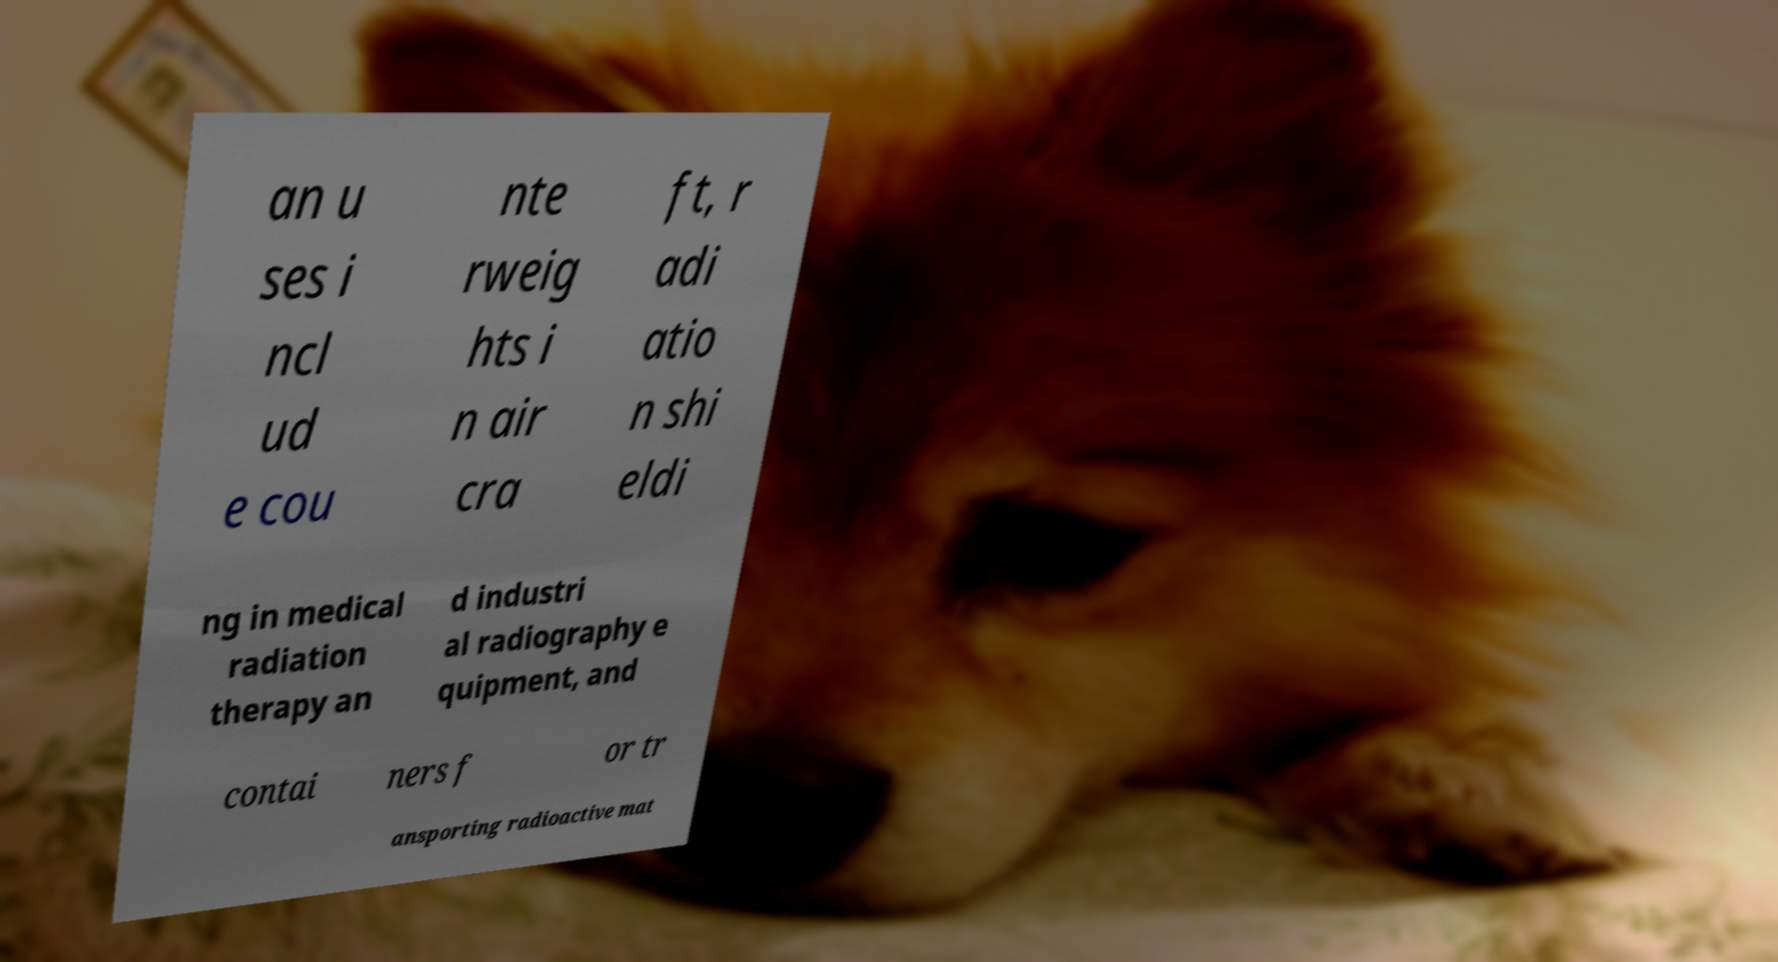Could you extract and type out the text from this image? an u ses i ncl ud e cou nte rweig hts i n air cra ft, r adi atio n shi eldi ng in medical radiation therapy an d industri al radiography e quipment, and contai ners f or tr ansporting radioactive mat 